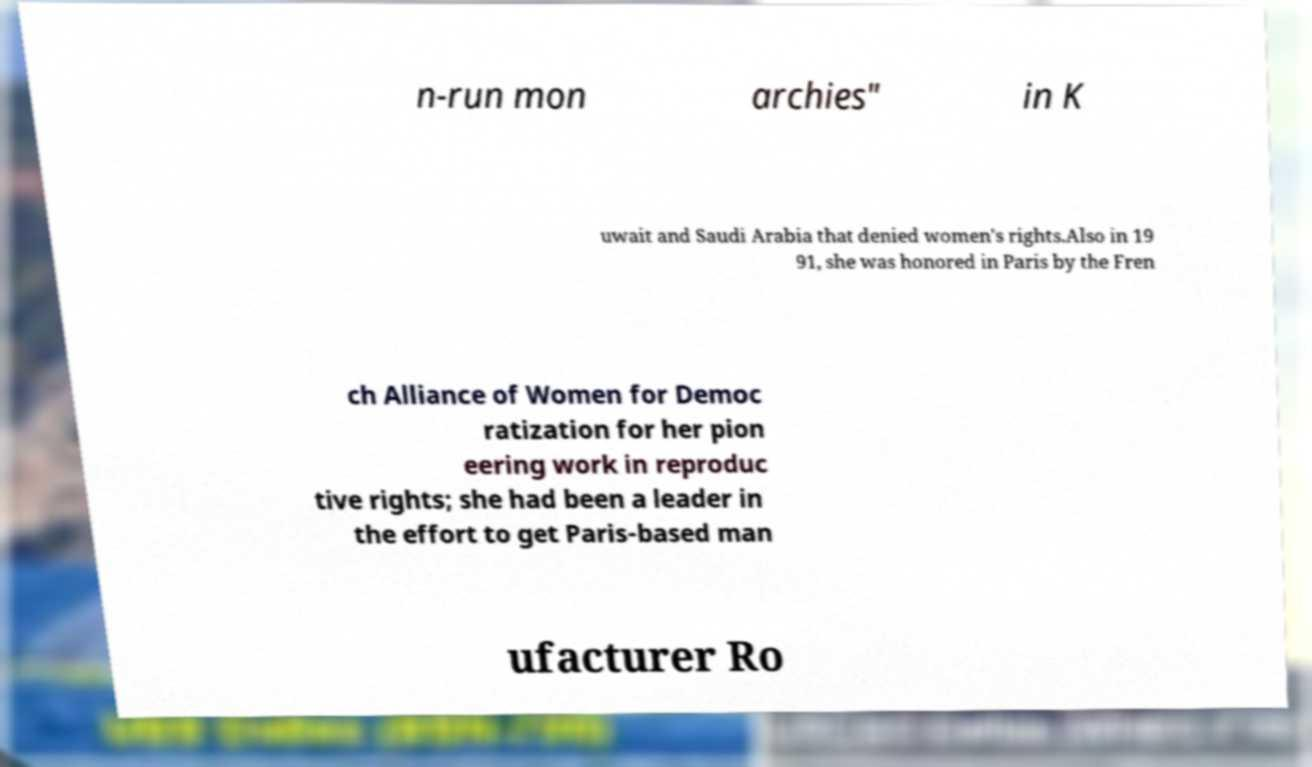I need the written content from this picture converted into text. Can you do that? n-run mon archies" in K uwait and Saudi Arabia that denied women's rights.Also in 19 91, she was honored in Paris by the Fren ch Alliance of Women for Democ ratization for her pion eering work in reproduc tive rights; she had been a leader in the effort to get Paris-based man ufacturer Ro 